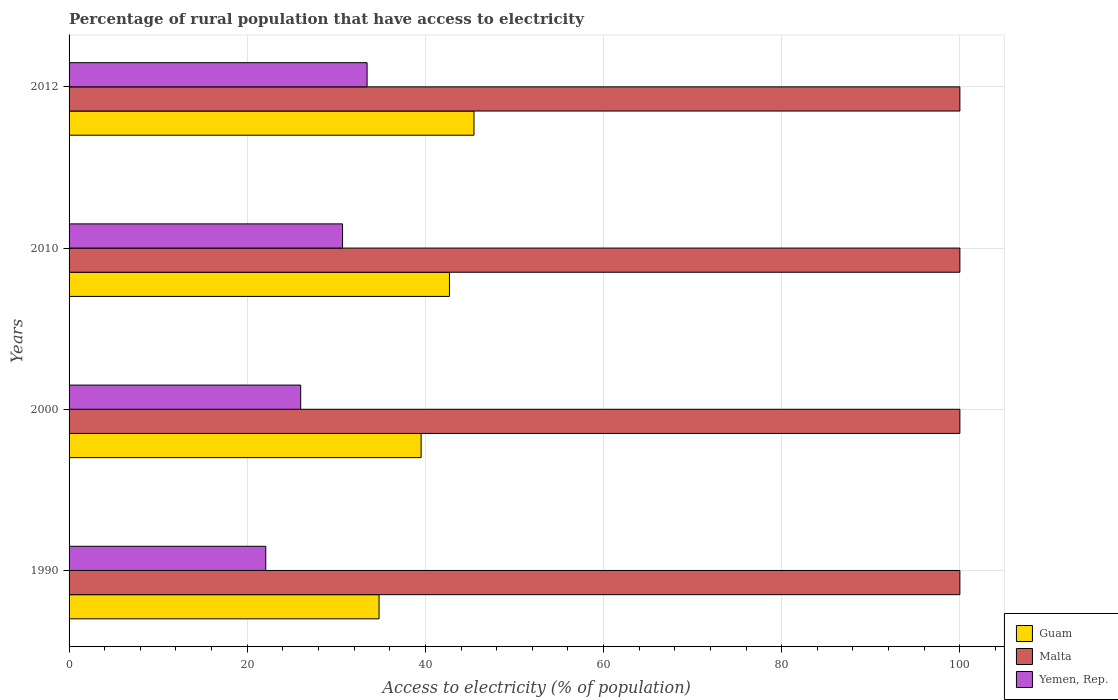What is the percentage of rural population that have access to electricity in Malta in 2000?
Provide a short and direct response. 100. Across all years, what is the maximum percentage of rural population that have access to electricity in Guam?
Give a very brief answer. 45.45. Across all years, what is the minimum percentage of rural population that have access to electricity in Malta?
Offer a terse response. 100. What is the total percentage of rural population that have access to electricity in Malta in the graph?
Offer a very short reply. 400. What is the difference between the percentage of rural population that have access to electricity in Yemen, Rep. in 2010 and the percentage of rural population that have access to electricity in Malta in 2012?
Keep it short and to the point. -69.3. What is the average percentage of rural population that have access to electricity in Guam per year?
Ensure brevity in your answer.  40.62. In the year 2000, what is the difference between the percentage of rural population that have access to electricity in Guam and percentage of rural population that have access to electricity in Malta?
Provide a short and direct response. -60.48. What is the ratio of the percentage of rural population that have access to electricity in Guam in 1990 to that in 2012?
Ensure brevity in your answer.  0.77. Is the percentage of rural population that have access to electricity in Yemen, Rep. in 2000 less than that in 2012?
Offer a terse response. Yes. Is the difference between the percentage of rural population that have access to electricity in Guam in 2010 and 2012 greater than the difference between the percentage of rural population that have access to electricity in Malta in 2010 and 2012?
Offer a terse response. No. What is the difference between the highest and the second highest percentage of rural population that have access to electricity in Yemen, Rep.?
Make the answer very short. 2.75. What is the difference between the highest and the lowest percentage of rural population that have access to electricity in Yemen, Rep.?
Ensure brevity in your answer.  11.38. In how many years, is the percentage of rural population that have access to electricity in Malta greater than the average percentage of rural population that have access to electricity in Malta taken over all years?
Provide a short and direct response. 0. What does the 1st bar from the top in 2010 represents?
Provide a succinct answer. Yemen, Rep. What does the 3rd bar from the bottom in 2000 represents?
Give a very brief answer. Yemen, Rep. Is it the case that in every year, the sum of the percentage of rural population that have access to electricity in Yemen, Rep. and percentage of rural population that have access to electricity in Guam is greater than the percentage of rural population that have access to electricity in Malta?
Provide a short and direct response. No. How many bars are there?
Give a very brief answer. 12. Are all the bars in the graph horizontal?
Keep it short and to the point. Yes. How many years are there in the graph?
Give a very brief answer. 4. What is the difference between two consecutive major ticks on the X-axis?
Provide a short and direct response. 20. Does the graph contain any zero values?
Offer a terse response. No. Does the graph contain grids?
Provide a succinct answer. Yes. Where does the legend appear in the graph?
Your response must be concise. Bottom right. What is the title of the graph?
Make the answer very short. Percentage of rural population that have access to electricity. What is the label or title of the X-axis?
Keep it short and to the point. Access to electricity (% of population). What is the label or title of the Y-axis?
Your answer should be very brief. Years. What is the Access to electricity (% of population) of Guam in 1990?
Offer a very short reply. 34.8. What is the Access to electricity (% of population) of Yemen, Rep. in 1990?
Provide a short and direct response. 22.08. What is the Access to electricity (% of population) of Guam in 2000?
Your answer should be compact. 39.52. What is the Access to electricity (% of population) of Yemen, Rep. in 2000?
Give a very brief answer. 26. What is the Access to electricity (% of population) in Guam in 2010?
Make the answer very short. 42.7. What is the Access to electricity (% of population) in Yemen, Rep. in 2010?
Your answer should be very brief. 30.7. What is the Access to electricity (% of population) in Guam in 2012?
Provide a succinct answer. 45.45. What is the Access to electricity (% of population) of Yemen, Rep. in 2012?
Make the answer very short. 33.45. Across all years, what is the maximum Access to electricity (% of population) of Guam?
Provide a short and direct response. 45.45. Across all years, what is the maximum Access to electricity (% of population) of Malta?
Ensure brevity in your answer.  100. Across all years, what is the maximum Access to electricity (% of population) in Yemen, Rep.?
Give a very brief answer. 33.45. Across all years, what is the minimum Access to electricity (% of population) of Guam?
Your response must be concise. 34.8. Across all years, what is the minimum Access to electricity (% of population) in Malta?
Offer a very short reply. 100. Across all years, what is the minimum Access to electricity (% of population) in Yemen, Rep.?
Make the answer very short. 22.08. What is the total Access to electricity (% of population) of Guam in the graph?
Offer a terse response. 162.47. What is the total Access to electricity (% of population) in Malta in the graph?
Keep it short and to the point. 400. What is the total Access to electricity (% of population) in Yemen, Rep. in the graph?
Keep it short and to the point. 112.23. What is the difference between the Access to electricity (% of population) of Guam in 1990 and that in 2000?
Your response must be concise. -4.72. What is the difference between the Access to electricity (% of population) in Yemen, Rep. in 1990 and that in 2000?
Offer a terse response. -3.92. What is the difference between the Access to electricity (% of population) of Guam in 1990 and that in 2010?
Your answer should be very brief. -7.9. What is the difference between the Access to electricity (% of population) in Yemen, Rep. in 1990 and that in 2010?
Your answer should be compact. -8.62. What is the difference between the Access to electricity (% of population) in Guam in 1990 and that in 2012?
Provide a short and direct response. -10.66. What is the difference between the Access to electricity (% of population) in Yemen, Rep. in 1990 and that in 2012?
Your response must be concise. -11.38. What is the difference between the Access to electricity (% of population) in Guam in 2000 and that in 2010?
Provide a short and direct response. -3.18. What is the difference between the Access to electricity (% of population) in Yemen, Rep. in 2000 and that in 2010?
Provide a succinct answer. -4.7. What is the difference between the Access to electricity (% of population) in Guam in 2000 and that in 2012?
Your answer should be compact. -5.93. What is the difference between the Access to electricity (% of population) in Malta in 2000 and that in 2012?
Provide a short and direct response. 0. What is the difference between the Access to electricity (% of population) in Yemen, Rep. in 2000 and that in 2012?
Your response must be concise. -7.45. What is the difference between the Access to electricity (% of population) in Guam in 2010 and that in 2012?
Your answer should be very brief. -2.75. What is the difference between the Access to electricity (% of population) in Malta in 2010 and that in 2012?
Provide a succinct answer. 0. What is the difference between the Access to electricity (% of population) in Yemen, Rep. in 2010 and that in 2012?
Give a very brief answer. -2.75. What is the difference between the Access to electricity (% of population) of Guam in 1990 and the Access to electricity (% of population) of Malta in 2000?
Your response must be concise. -65.2. What is the difference between the Access to electricity (% of population) of Guam in 1990 and the Access to electricity (% of population) of Yemen, Rep. in 2000?
Provide a short and direct response. 8.8. What is the difference between the Access to electricity (% of population) in Malta in 1990 and the Access to electricity (% of population) in Yemen, Rep. in 2000?
Your response must be concise. 74. What is the difference between the Access to electricity (% of population) in Guam in 1990 and the Access to electricity (% of population) in Malta in 2010?
Offer a terse response. -65.2. What is the difference between the Access to electricity (% of population) in Guam in 1990 and the Access to electricity (% of population) in Yemen, Rep. in 2010?
Offer a terse response. 4.1. What is the difference between the Access to electricity (% of population) in Malta in 1990 and the Access to electricity (% of population) in Yemen, Rep. in 2010?
Your response must be concise. 69.3. What is the difference between the Access to electricity (% of population) of Guam in 1990 and the Access to electricity (% of population) of Malta in 2012?
Your response must be concise. -65.2. What is the difference between the Access to electricity (% of population) in Guam in 1990 and the Access to electricity (% of population) in Yemen, Rep. in 2012?
Your response must be concise. 1.34. What is the difference between the Access to electricity (% of population) of Malta in 1990 and the Access to electricity (% of population) of Yemen, Rep. in 2012?
Offer a very short reply. 66.55. What is the difference between the Access to electricity (% of population) in Guam in 2000 and the Access to electricity (% of population) in Malta in 2010?
Offer a terse response. -60.48. What is the difference between the Access to electricity (% of population) of Guam in 2000 and the Access to electricity (% of population) of Yemen, Rep. in 2010?
Your response must be concise. 8.82. What is the difference between the Access to electricity (% of population) of Malta in 2000 and the Access to electricity (% of population) of Yemen, Rep. in 2010?
Offer a terse response. 69.3. What is the difference between the Access to electricity (% of population) in Guam in 2000 and the Access to electricity (% of population) in Malta in 2012?
Keep it short and to the point. -60.48. What is the difference between the Access to electricity (% of population) of Guam in 2000 and the Access to electricity (% of population) of Yemen, Rep. in 2012?
Provide a short and direct response. 6.07. What is the difference between the Access to electricity (% of population) in Malta in 2000 and the Access to electricity (% of population) in Yemen, Rep. in 2012?
Ensure brevity in your answer.  66.55. What is the difference between the Access to electricity (% of population) in Guam in 2010 and the Access to electricity (% of population) in Malta in 2012?
Make the answer very short. -57.3. What is the difference between the Access to electricity (% of population) of Guam in 2010 and the Access to electricity (% of population) of Yemen, Rep. in 2012?
Offer a terse response. 9.25. What is the difference between the Access to electricity (% of population) of Malta in 2010 and the Access to electricity (% of population) of Yemen, Rep. in 2012?
Your response must be concise. 66.55. What is the average Access to electricity (% of population) in Guam per year?
Keep it short and to the point. 40.62. What is the average Access to electricity (% of population) of Malta per year?
Ensure brevity in your answer.  100. What is the average Access to electricity (% of population) of Yemen, Rep. per year?
Make the answer very short. 28.06. In the year 1990, what is the difference between the Access to electricity (% of population) of Guam and Access to electricity (% of population) of Malta?
Keep it short and to the point. -65.2. In the year 1990, what is the difference between the Access to electricity (% of population) in Guam and Access to electricity (% of population) in Yemen, Rep.?
Make the answer very short. 12.72. In the year 1990, what is the difference between the Access to electricity (% of population) in Malta and Access to electricity (% of population) in Yemen, Rep.?
Keep it short and to the point. 77.92. In the year 2000, what is the difference between the Access to electricity (% of population) in Guam and Access to electricity (% of population) in Malta?
Provide a short and direct response. -60.48. In the year 2000, what is the difference between the Access to electricity (% of population) of Guam and Access to electricity (% of population) of Yemen, Rep.?
Give a very brief answer. 13.52. In the year 2010, what is the difference between the Access to electricity (% of population) in Guam and Access to electricity (% of population) in Malta?
Give a very brief answer. -57.3. In the year 2010, what is the difference between the Access to electricity (% of population) in Malta and Access to electricity (% of population) in Yemen, Rep.?
Ensure brevity in your answer.  69.3. In the year 2012, what is the difference between the Access to electricity (% of population) of Guam and Access to electricity (% of population) of Malta?
Offer a very short reply. -54.55. In the year 2012, what is the difference between the Access to electricity (% of population) of Guam and Access to electricity (% of population) of Yemen, Rep.?
Your answer should be very brief. 12. In the year 2012, what is the difference between the Access to electricity (% of population) in Malta and Access to electricity (% of population) in Yemen, Rep.?
Ensure brevity in your answer.  66.55. What is the ratio of the Access to electricity (% of population) in Guam in 1990 to that in 2000?
Your answer should be compact. 0.88. What is the ratio of the Access to electricity (% of population) in Malta in 1990 to that in 2000?
Provide a succinct answer. 1. What is the ratio of the Access to electricity (% of population) of Yemen, Rep. in 1990 to that in 2000?
Give a very brief answer. 0.85. What is the ratio of the Access to electricity (% of population) in Guam in 1990 to that in 2010?
Make the answer very short. 0.81. What is the ratio of the Access to electricity (% of population) of Malta in 1990 to that in 2010?
Provide a short and direct response. 1. What is the ratio of the Access to electricity (% of population) in Yemen, Rep. in 1990 to that in 2010?
Offer a terse response. 0.72. What is the ratio of the Access to electricity (% of population) of Guam in 1990 to that in 2012?
Your response must be concise. 0.77. What is the ratio of the Access to electricity (% of population) of Yemen, Rep. in 1990 to that in 2012?
Provide a short and direct response. 0.66. What is the ratio of the Access to electricity (% of population) of Guam in 2000 to that in 2010?
Give a very brief answer. 0.93. What is the ratio of the Access to electricity (% of population) of Yemen, Rep. in 2000 to that in 2010?
Ensure brevity in your answer.  0.85. What is the ratio of the Access to electricity (% of population) of Guam in 2000 to that in 2012?
Give a very brief answer. 0.87. What is the ratio of the Access to electricity (% of population) of Yemen, Rep. in 2000 to that in 2012?
Offer a very short reply. 0.78. What is the ratio of the Access to electricity (% of population) of Guam in 2010 to that in 2012?
Your answer should be very brief. 0.94. What is the ratio of the Access to electricity (% of population) of Malta in 2010 to that in 2012?
Provide a succinct answer. 1. What is the ratio of the Access to electricity (% of population) in Yemen, Rep. in 2010 to that in 2012?
Your answer should be compact. 0.92. What is the difference between the highest and the second highest Access to electricity (% of population) in Guam?
Your answer should be very brief. 2.75. What is the difference between the highest and the second highest Access to electricity (% of population) in Yemen, Rep.?
Offer a very short reply. 2.75. What is the difference between the highest and the lowest Access to electricity (% of population) in Guam?
Your answer should be very brief. 10.66. What is the difference between the highest and the lowest Access to electricity (% of population) in Malta?
Keep it short and to the point. 0. What is the difference between the highest and the lowest Access to electricity (% of population) of Yemen, Rep.?
Make the answer very short. 11.38. 